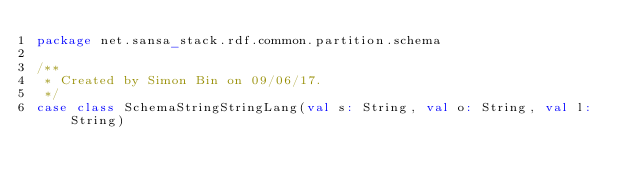Convert code to text. <code><loc_0><loc_0><loc_500><loc_500><_Scala_>package net.sansa_stack.rdf.common.partition.schema

/**
 * Created by Simon Bin on 09/06/17.
 */
case class SchemaStringStringLang(val s: String, val o: String, val l: String)
</code> 